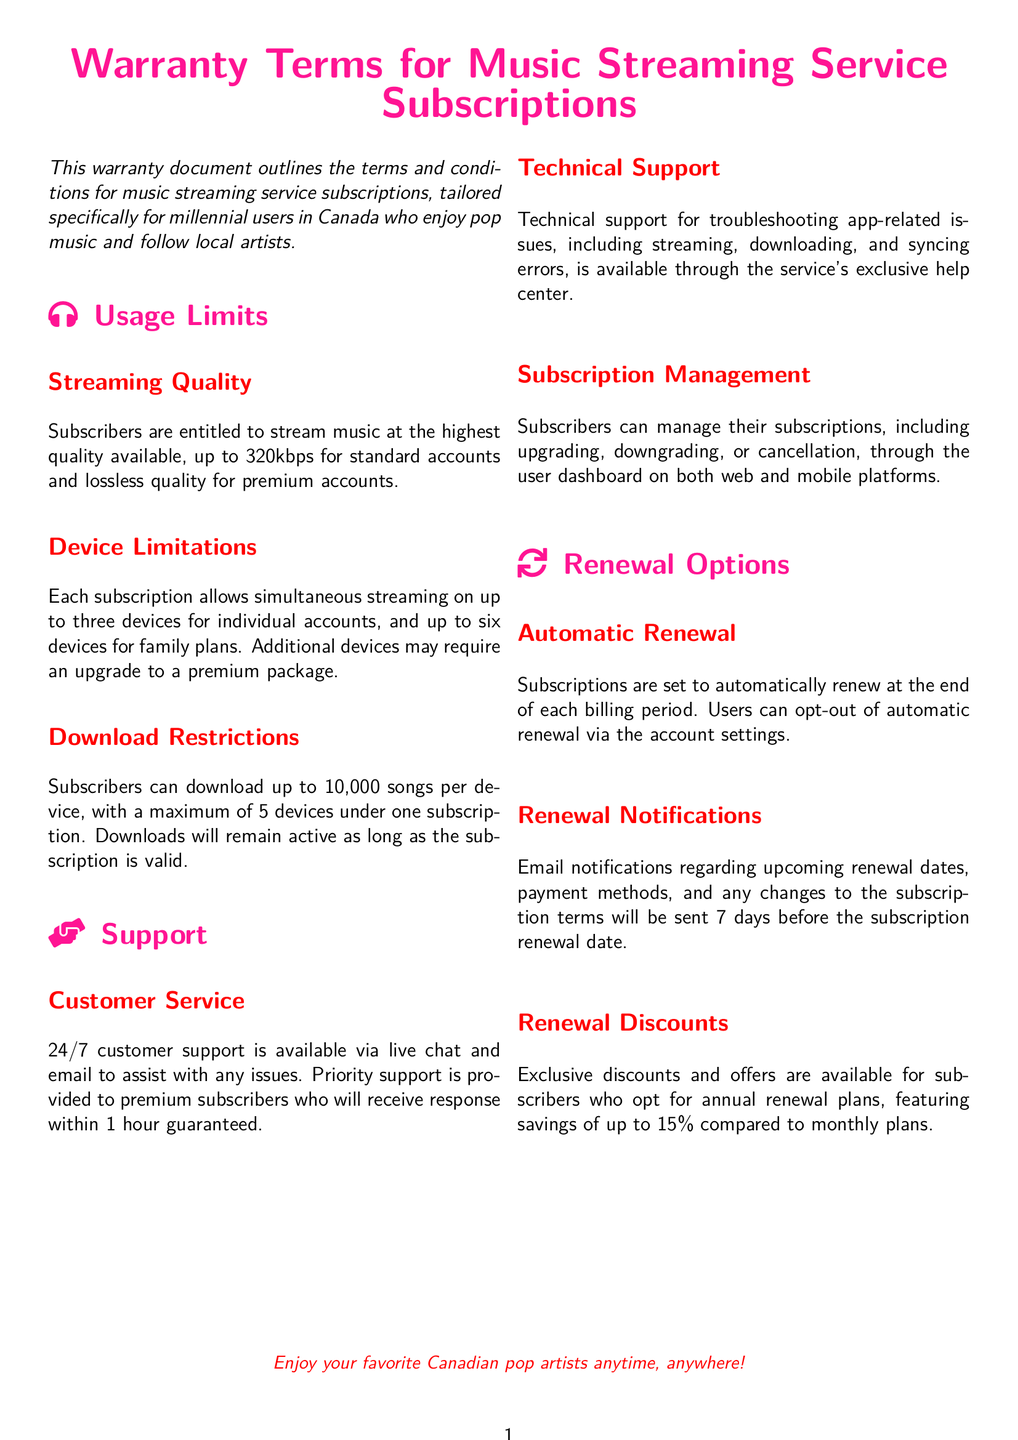What is the maximum streaming quality for standard accounts? The document specifies that subscribers are entitled to stream music at the highest quality available, which is up to 320kbps for standard accounts.
Answer: 320kbps How many devices can stream simultaneously on a family plan? The document states that a family plan allows simultaneous streaming on up to six devices.
Answer: six What is the maximum number of songs that can be downloaded per device? According to the document, subscribers can download up to 10,000 songs per device.
Answer: 10,000 What kind of support is guaranteed within 1 hour for premium subscribers? It is mentioned that priority support is provided to premium subscribers who will receive a response within 1 hour guaranteed.
Answer: priority support What percentage discount is available for annual renewal plans? The document notes that exclusive discounts for annual renewal plans feature savings of up to 15% compared to monthly plans.
Answer: 15% How can subscribers manage their subscriptions? Subscribers can manage their subscriptions through the user dashboard on both web and mobile platforms, as stated in the document.
Answer: user dashboard What type of notifications will subscribers receive before renewal? The document indicates that email notifications regarding upcoming renewal dates will be sent 7 days prior to the renewal date.
Answer: email notifications What is required to opt-out of automatic renewal? To opt-out of automatic renewal, users must change settings in their account, as stated in the warranty terms.
Answer: account settings 